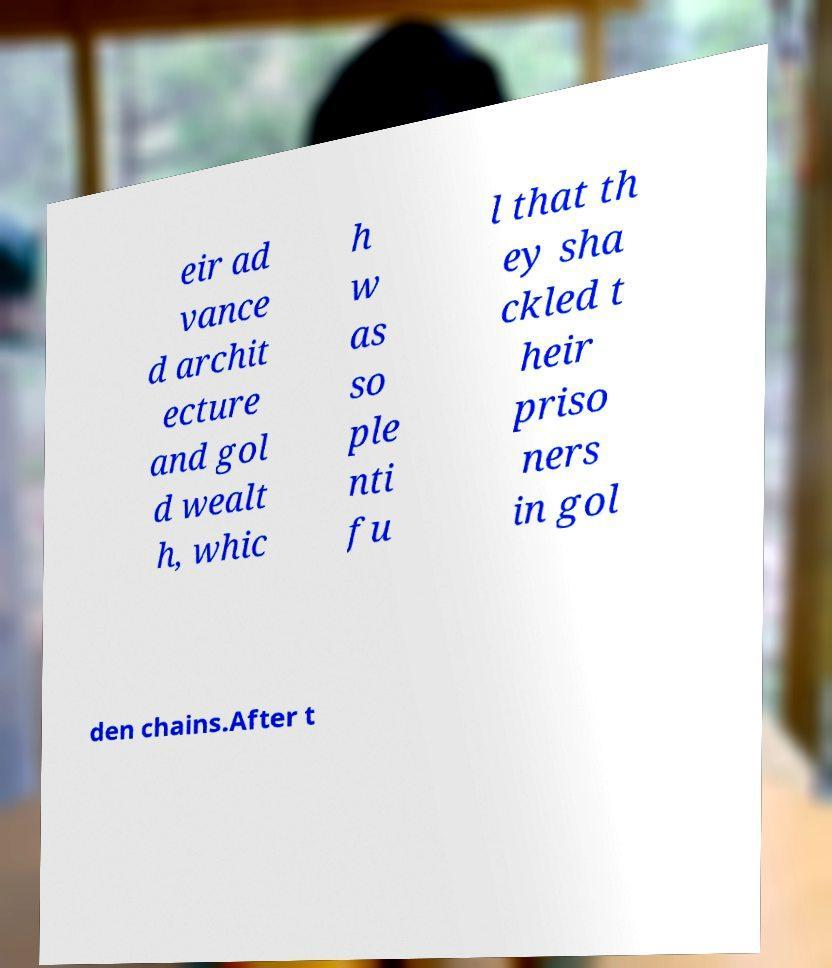Could you assist in decoding the text presented in this image and type it out clearly? eir ad vance d archit ecture and gol d wealt h, whic h w as so ple nti fu l that th ey sha ckled t heir priso ners in gol den chains.After t 